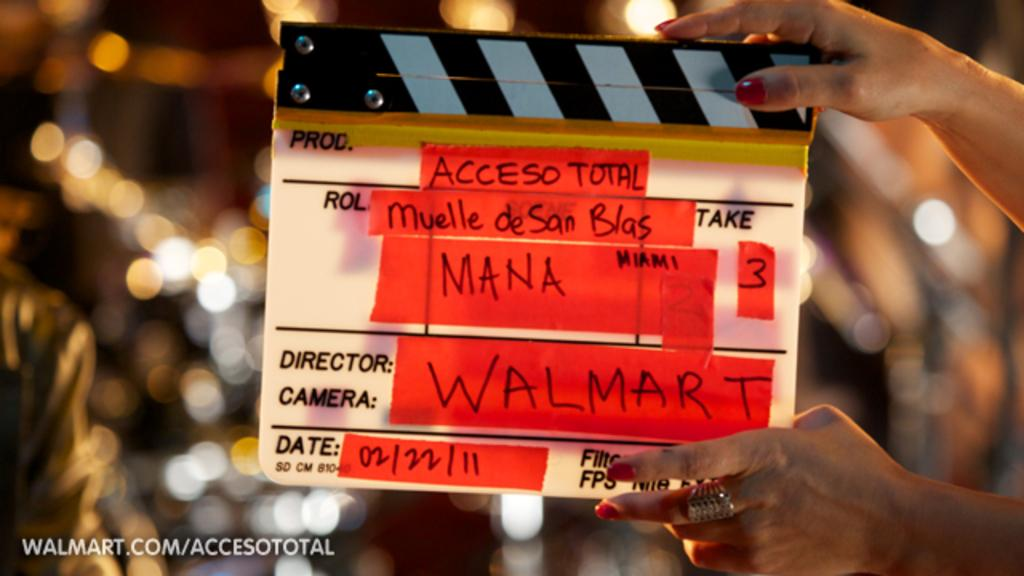Who or what is the main subject in the image? There is a person in the image. What is the person holding in the image? The person is holding a hand clapboard. What can be found on the hand clapboard? There is writing on the hand clapboard. What can be seen in the background of the image? There are lights visible in the background. What type of education is being taught in the image? There is no indication of education being taught in the image; it features a person holding a hand clapboard. How many twists are visible in the image? There are no twists visible in the image. 